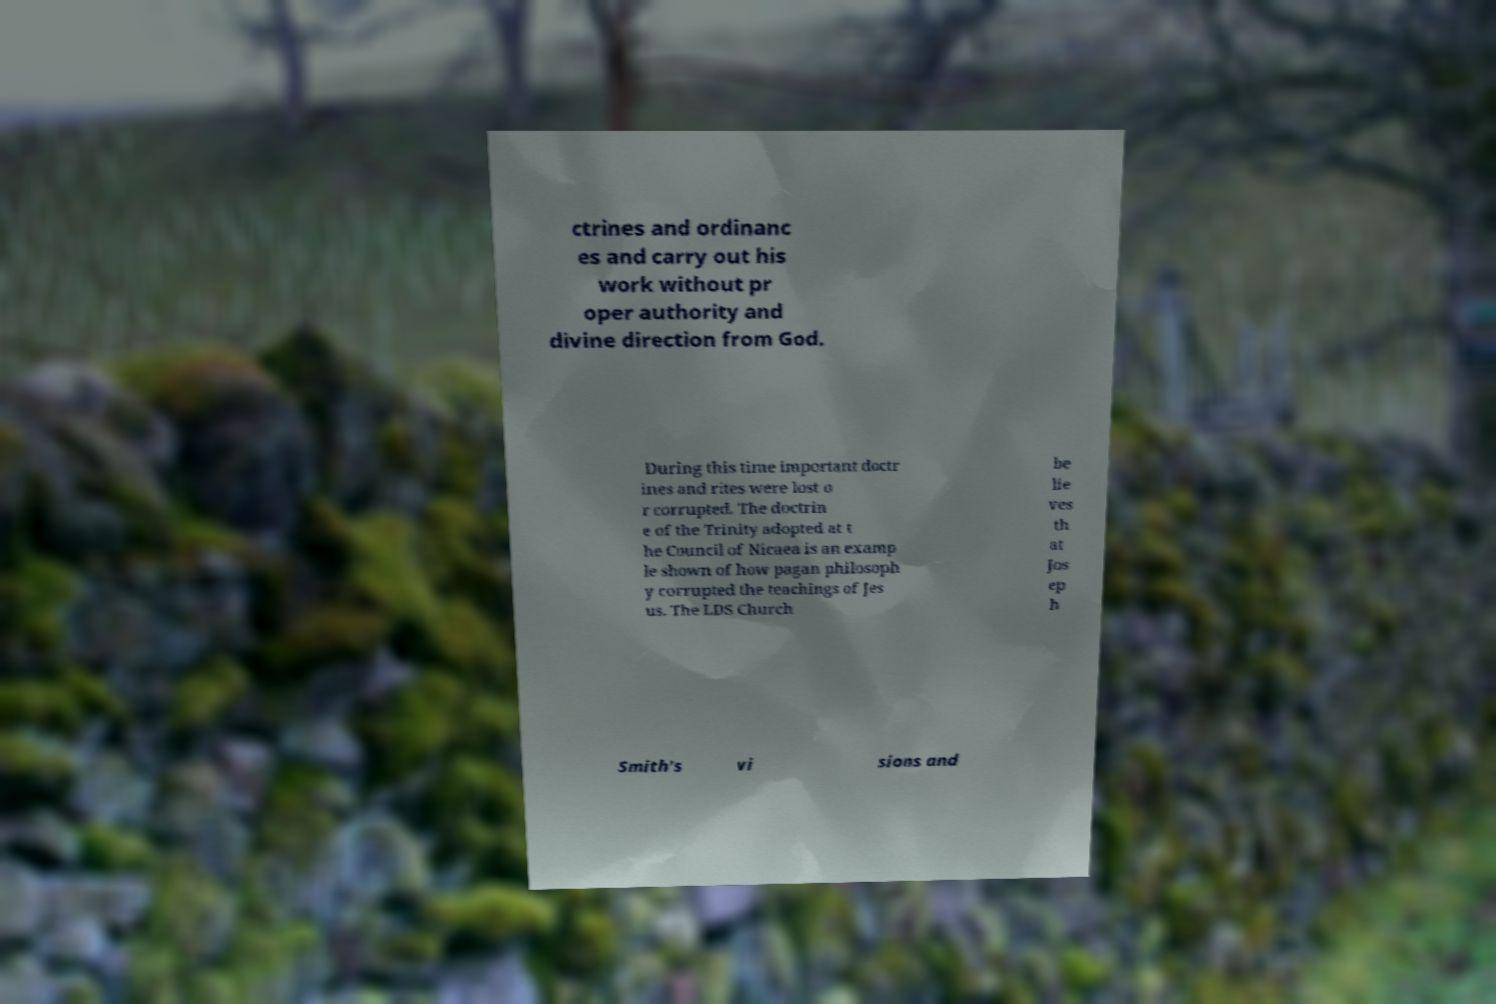Could you extract and type out the text from this image? ctrines and ordinanc es and carry out his work without pr oper authority and divine direction from God. During this time important doctr ines and rites were lost o r corrupted. The doctrin e of the Trinity adopted at t he Council of Nicaea is an examp le shown of how pagan philosoph y corrupted the teachings of Jes us. The LDS Church be lie ves th at Jos ep h Smith's vi sions and 